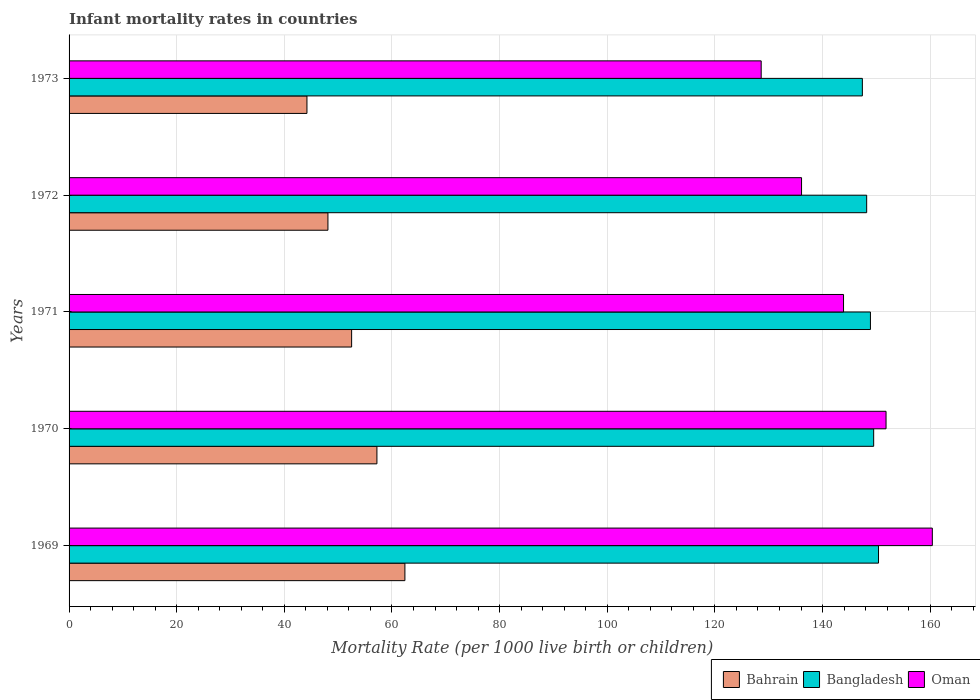How many different coloured bars are there?
Offer a terse response. 3. Are the number of bars per tick equal to the number of legend labels?
Offer a very short reply. Yes. How many bars are there on the 2nd tick from the top?
Ensure brevity in your answer.  3. How many bars are there on the 4th tick from the bottom?
Ensure brevity in your answer.  3. In how many cases, is the number of bars for a given year not equal to the number of legend labels?
Your response must be concise. 0. What is the infant mortality rate in Bahrain in 1970?
Make the answer very short. 57.2. Across all years, what is the maximum infant mortality rate in Oman?
Make the answer very short. 160.4. Across all years, what is the minimum infant mortality rate in Bahrain?
Give a very brief answer. 44.2. In which year was the infant mortality rate in Bahrain maximum?
Your answer should be compact. 1969. In which year was the infant mortality rate in Bahrain minimum?
Your answer should be compact. 1973. What is the total infant mortality rate in Bangladesh in the graph?
Offer a terse response. 744.4. What is the difference between the infant mortality rate in Oman in 1970 and the infant mortality rate in Bahrain in 1971?
Your answer should be very brief. 99.3. What is the average infant mortality rate in Bangladesh per year?
Your answer should be compact. 148.88. In the year 1970, what is the difference between the infant mortality rate in Oman and infant mortality rate in Bangladesh?
Your answer should be very brief. 2.3. In how many years, is the infant mortality rate in Bangladesh greater than 152 ?
Provide a short and direct response. 0. What is the ratio of the infant mortality rate in Bahrain in 1970 to that in 1973?
Offer a very short reply. 1.29. What is the difference between the highest and the second highest infant mortality rate in Bangladesh?
Give a very brief answer. 0.9. In how many years, is the infant mortality rate in Oman greater than the average infant mortality rate in Oman taken over all years?
Provide a short and direct response. 2. What does the 1st bar from the top in 1972 represents?
Your response must be concise. Oman. What does the 2nd bar from the bottom in 1969 represents?
Give a very brief answer. Bangladesh. How many bars are there?
Your answer should be very brief. 15. Does the graph contain any zero values?
Give a very brief answer. No. How many legend labels are there?
Your response must be concise. 3. What is the title of the graph?
Your response must be concise. Infant mortality rates in countries. Does "Antigua and Barbuda" appear as one of the legend labels in the graph?
Your answer should be very brief. No. What is the label or title of the X-axis?
Your answer should be compact. Mortality Rate (per 1000 live birth or children). What is the Mortality Rate (per 1000 live birth or children) of Bahrain in 1969?
Ensure brevity in your answer.  62.4. What is the Mortality Rate (per 1000 live birth or children) of Bangladesh in 1969?
Offer a very short reply. 150.4. What is the Mortality Rate (per 1000 live birth or children) in Oman in 1969?
Provide a short and direct response. 160.4. What is the Mortality Rate (per 1000 live birth or children) of Bahrain in 1970?
Your answer should be very brief. 57.2. What is the Mortality Rate (per 1000 live birth or children) in Bangladesh in 1970?
Ensure brevity in your answer.  149.5. What is the Mortality Rate (per 1000 live birth or children) of Oman in 1970?
Your response must be concise. 151.8. What is the Mortality Rate (per 1000 live birth or children) of Bahrain in 1971?
Your response must be concise. 52.5. What is the Mortality Rate (per 1000 live birth or children) in Bangladesh in 1971?
Provide a succinct answer. 148.9. What is the Mortality Rate (per 1000 live birth or children) of Oman in 1971?
Your response must be concise. 143.9. What is the Mortality Rate (per 1000 live birth or children) of Bahrain in 1972?
Offer a terse response. 48.1. What is the Mortality Rate (per 1000 live birth or children) in Bangladesh in 1972?
Offer a terse response. 148.2. What is the Mortality Rate (per 1000 live birth or children) in Oman in 1972?
Offer a very short reply. 136.1. What is the Mortality Rate (per 1000 live birth or children) of Bahrain in 1973?
Give a very brief answer. 44.2. What is the Mortality Rate (per 1000 live birth or children) of Bangladesh in 1973?
Provide a short and direct response. 147.4. What is the Mortality Rate (per 1000 live birth or children) of Oman in 1973?
Provide a succinct answer. 128.6. Across all years, what is the maximum Mortality Rate (per 1000 live birth or children) of Bahrain?
Make the answer very short. 62.4. Across all years, what is the maximum Mortality Rate (per 1000 live birth or children) in Bangladesh?
Make the answer very short. 150.4. Across all years, what is the maximum Mortality Rate (per 1000 live birth or children) of Oman?
Provide a succinct answer. 160.4. Across all years, what is the minimum Mortality Rate (per 1000 live birth or children) in Bahrain?
Keep it short and to the point. 44.2. Across all years, what is the minimum Mortality Rate (per 1000 live birth or children) in Bangladesh?
Make the answer very short. 147.4. Across all years, what is the minimum Mortality Rate (per 1000 live birth or children) in Oman?
Offer a very short reply. 128.6. What is the total Mortality Rate (per 1000 live birth or children) in Bahrain in the graph?
Give a very brief answer. 264.4. What is the total Mortality Rate (per 1000 live birth or children) of Bangladesh in the graph?
Offer a terse response. 744.4. What is the total Mortality Rate (per 1000 live birth or children) of Oman in the graph?
Ensure brevity in your answer.  720.8. What is the difference between the Mortality Rate (per 1000 live birth or children) in Bahrain in 1969 and that in 1970?
Give a very brief answer. 5.2. What is the difference between the Mortality Rate (per 1000 live birth or children) of Bangladesh in 1969 and that in 1970?
Offer a terse response. 0.9. What is the difference between the Mortality Rate (per 1000 live birth or children) of Oman in 1969 and that in 1970?
Ensure brevity in your answer.  8.6. What is the difference between the Mortality Rate (per 1000 live birth or children) in Bangladesh in 1969 and that in 1971?
Keep it short and to the point. 1.5. What is the difference between the Mortality Rate (per 1000 live birth or children) in Bahrain in 1969 and that in 1972?
Give a very brief answer. 14.3. What is the difference between the Mortality Rate (per 1000 live birth or children) of Bangladesh in 1969 and that in 1972?
Provide a succinct answer. 2.2. What is the difference between the Mortality Rate (per 1000 live birth or children) of Oman in 1969 and that in 1972?
Your answer should be very brief. 24.3. What is the difference between the Mortality Rate (per 1000 live birth or children) of Bahrain in 1969 and that in 1973?
Make the answer very short. 18.2. What is the difference between the Mortality Rate (per 1000 live birth or children) in Bangladesh in 1969 and that in 1973?
Provide a succinct answer. 3. What is the difference between the Mortality Rate (per 1000 live birth or children) of Oman in 1969 and that in 1973?
Your answer should be compact. 31.8. What is the difference between the Mortality Rate (per 1000 live birth or children) in Bahrain in 1970 and that in 1971?
Offer a very short reply. 4.7. What is the difference between the Mortality Rate (per 1000 live birth or children) of Oman in 1970 and that in 1971?
Give a very brief answer. 7.9. What is the difference between the Mortality Rate (per 1000 live birth or children) in Bahrain in 1970 and that in 1972?
Ensure brevity in your answer.  9.1. What is the difference between the Mortality Rate (per 1000 live birth or children) in Bangladesh in 1970 and that in 1972?
Make the answer very short. 1.3. What is the difference between the Mortality Rate (per 1000 live birth or children) of Oman in 1970 and that in 1973?
Keep it short and to the point. 23.2. What is the difference between the Mortality Rate (per 1000 live birth or children) in Bahrain in 1971 and that in 1972?
Make the answer very short. 4.4. What is the difference between the Mortality Rate (per 1000 live birth or children) of Bangladesh in 1971 and that in 1972?
Keep it short and to the point. 0.7. What is the difference between the Mortality Rate (per 1000 live birth or children) in Bangladesh in 1971 and that in 1973?
Your response must be concise. 1.5. What is the difference between the Mortality Rate (per 1000 live birth or children) of Oman in 1971 and that in 1973?
Make the answer very short. 15.3. What is the difference between the Mortality Rate (per 1000 live birth or children) of Bangladesh in 1972 and that in 1973?
Provide a short and direct response. 0.8. What is the difference between the Mortality Rate (per 1000 live birth or children) of Oman in 1972 and that in 1973?
Provide a short and direct response. 7.5. What is the difference between the Mortality Rate (per 1000 live birth or children) of Bahrain in 1969 and the Mortality Rate (per 1000 live birth or children) of Bangladesh in 1970?
Offer a very short reply. -87.1. What is the difference between the Mortality Rate (per 1000 live birth or children) in Bahrain in 1969 and the Mortality Rate (per 1000 live birth or children) in Oman in 1970?
Offer a terse response. -89.4. What is the difference between the Mortality Rate (per 1000 live birth or children) in Bahrain in 1969 and the Mortality Rate (per 1000 live birth or children) in Bangladesh in 1971?
Give a very brief answer. -86.5. What is the difference between the Mortality Rate (per 1000 live birth or children) of Bahrain in 1969 and the Mortality Rate (per 1000 live birth or children) of Oman in 1971?
Provide a succinct answer. -81.5. What is the difference between the Mortality Rate (per 1000 live birth or children) of Bahrain in 1969 and the Mortality Rate (per 1000 live birth or children) of Bangladesh in 1972?
Your answer should be compact. -85.8. What is the difference between the Mortality Rate (per 1000 live birth or children) in Bahrain in 1969 and the Mortality Rate (per 1000 live birth or children) in Oman in 1972?
Your answer should be compact. -73.7. What is the difference between the Mortality Rate (per 1000 live birth or children) in Bahrain in 1969 and the Mortality Rate (per 1000 live birth or children) in Bangladesh in 1973?
Provide a short and direct response. -85. What is the difference between the Mortality Rate (per 1000 live birth or children) of Bahrain in 1969 and the Mortality Rate (per 1000 live birth or children) of Oman in 1973?
Your response must be concise. -66.2. What is the difference between the Mortality Rate (per 1000 live birth or children) of Bangladesh in 1969 and the Mortality Rate (per 1000 live birth or children) of Oman in 1973?
Ensure brevity in your answer.  21.8. What is the difference between the Mortality Rate (per 1000 live birth or children) of Bahrain in 1970 and the Mortality Rate (per 1000 live birth or children) of Bangladesh in 1971?
Offer a terse response. -91.7. What is the difference between the Mortality Rate (per 1000 live birth or children) of Bahrain in 1970 and the Mortality Rate (per 1000 live birth or children) of Oman in 1971?
Keep it short and to the point. -86.7. What is the difference between the Mortality Rate (per 1000 live birth or children) in Bangladesh in 1970 and the Mortality Rate (per 1000 live birth or children) in Oman in 1971?
Provide a short and direct response. 5.6. What is the difference between the Mortality Rate (per 1000 live birth or children) of Bahrain in 1970 and the Mortality Rate (per 1000 live birth or children) of Bangladesh in 1972?
Make the answer very short. -91. What is the difference between the Mortality Rate (per 1000 live birth or children) in Bahrain in 1970 and the Mortality Rate (per 1000 live birth or children) in Oman in 1972?
Your answer should be compact. -78.9. What is the difference between the Mortality Rate (per 1000 live birth or children) in Bangladesh in 1970 and the Mortality Rate (per 1000 live birth or children) in Oman in 1972?
Offer a terse response. 13.4. What is the difference between the Mortality Rate (per 1000 live birth or children) of Bahrain in 1970 and the Mortality Rate (per 1000 live birth or children) of Bangladesh in 1973?
Give a very brief answer. -90.2. What is the difference between the Mortality Rate (per 1000 live birth or children) of Bahrain in 1970 and the Mortality Rate (per 1000 live birth or children) of Oman in 1973?
Your response must be concise. -71.4. What is the difference between the Mortality Rate (per 1000 live birth or children) in Bangladesh in 1970 and the Mortality Rate (per 1000 live birth or children) in Oman in 1973?
Provide a succinct answer. 20.9. What is the difference between the Mortality Rate (per 1000 live birth or children) in Bahrain in 1971 and the Mortality Rate (per 1000 live birth or children) in Bangladesh in 1972?
Ensure brevity in your answer.  -95.7. What is the difference between the Mortality Rate (per 1000 live birth or children) of Bahrain in 1971 and the Mortality Rate (per 1000 live birth or children) of Oman in 1972?
Ensure brevity in your answer.  -83.6. What is the difference between the Mortality Rate (per 1000 live birth or children) in Bangladesh in 1971 and the Mortality Rate (per 1000 live birth or children) in Oman in 1972?
Your answer should be very brief. 12.8. What is the difference between the Mortality Rate (per 1000 live birth or children) of Bahrain in 1971 and the Mortality Rate (per 1000 live birth or children) of Bangladesh in 1973?
Provide a short and direct response. -94.9. What is the difference between the Mortality Rate (per 1000 live birth or children) in Bahrain in 1971 and the Mortality Rate (per 1000 live birth or children) in Oman in 1973?
Your answer should be compact. -76.1. What is the difference between the Mortality Rate (per 1000 live birth or children) of Bangladesh in 1971 and the Mortality Rate (per 1000 live birth or children) of Oman in 1973?
Your answer should be compact. 20.3. What is the difference between the Mortality Rate (per 1000 live birth or children) in Bahrain in 1972 and the Mortality Rate (per 1000 live birth or children) in Bangladesh in 1973?
Offer a very short reply. -99.3. What is the difference between the Mortality Rate (per 1000 live birth or children) in Bahrain in 1972 and the Mortality Rate (per 1000 live birth or children) in Oman in 1973?
Give a very brief answer. -80.5. What is the difference between the Mortality Rate (per 1000 live birth or children) of Bangladesh in 1972 and the Mortality Rate (per 1000 live birth or children) of Oman in 1973?
Your answer should be very brief. 19.6. What is the average Mortality Rate (per 1000 live birth or children) of Bahrain per year?
Provide a short and direct response. 52.88. What is the average Mortality Rate (per 1000 live birth or children) in Bangladesh per year?
Keep it short and to the point. 148.88. What is the average Mortality Rate (per 1000 live birth or children) in Oman per year?
Your answer should be very brief. 144.16. In the year 1969, what is the difference between the Mortality Rate (per 1000 live birth or children) in Bahrain and Mortality Rate (per 1000 live birth or children) in Bangladesh?
Ensure brevity in your answer.  -88. In the year 1969, what is the difference between the Mortality Rate (per 1000 live birth or children) in Bahrain and Mortality Rate (per 1000 live birth or children) in Oman?
Provide a short and direct response. -98. In the year 1970, what is the difference between the Mortality Rate (per 1000 live birth or children) of Bahrain and Mortality Rate (per 1000 live birth or children) of Bangladesh?
Your answer should be compact. -92.3. In the year 1970, what is the difference between the Mortality Rate (per 1000 live birth or children) in Bahrain and Mortality Rate (per 1000 live birth or children) in Oman?
Ensure brevity in your answer.  -94.6. In the year 1970, what is the difference between the Mortality Rate (per 1000 live birth or children) in Bangladesh and Mortality Rate (per 1000 live birth or children) in Oman?
Offer a terse response. -2.3. In the year 1971, what is the difference between the Mortality Rate (per 1000 live birth or children) of Bahrain and Mortality Rate (per 1000 live birth or children) of Bangladesh?
Ensure brevity in your answer.  -96.4. In the year 1971, what is the difference between the Mortality Rate (per 1000 live birth or children) of Bahrain and Mortality Rate (per 1000 live birth or children) of Oman?
Offer a very short reply. -91.4. In the year 1972, what is the difference between the Mortality Rate (per 1000 live birth or children) of Bahrain and Mortality Rate (per 1000 live birth or children) of Bangladesh?
Ensure brevity in your answer.  -100.1. In the year 1972, what is the difference between the Mortality Rate (per 1000 live birth or children) of Bahrain and Mortality Rate (per 1000 live birth or children) of Oman?
Provide a short and direct response. -88. In the year 1973, what is the difference between the Mortality Rate (per 1000 live birth or children) in Bahrain and Mortality Rate (per 1000 live birth or children) in Bangladesh?
Keep it short and to the point. -103.2. In the year 1973, what is the difference between the Mortality Rate (per 1000 live birth or children) in Bahrain and Mortality Rate (per 1000 live birth or children) in Oman?
Provide a succinct answer. -84.4. In the year 1973, what is the difference between the Mortality Rate (per 1000 live birth or children) of Bangladesh and Mortality Rate (per 1000 live birth or children) of Oman?
Your answer should be compact. 18.8. What is the ratio of the Mortality Rate (per 1000 live birth or children) in Bahrain in 1969 to that in 1970?
Offer a terse response. 1.09. What is the ratio of the Mortality Rate (per 1000 live birth or children) in Bangladesh in 1969 to that in 1970?
Ensure brevity in your answer.  1.01. What is the ratio of the Mortality Rate (per 1000 live birth or children) of Oman in 1969 to that in 1970?
Keep it short and to the point. 1.06. What is the ratio of the Mortality Rate (per 1000 live birth or children) of Bahrain in 1969 to that in 1971?
Offer a terse response. 1.19. What is the ratio of the Mortality Rate (per 1000 live birth or children) of Bangladesh in 1969 to that in 1971?
Your response must be concise. 1.01. What is the ratio of the Mortality Rate (per 1000 live birth or children) in Oman in 1969 to that in 1971?
Your response must be concise. 1.11. What is the ratio of the Mortality Rate (per 1000 live birth or children) in Bahrain in 1969 to that in 1972?
Make the answer very short. 1.3. What is the ratio of the Mortality Rate (per 1000 live birth or children) in Bangladesh in 1969 to that in 1972?
Ensure brevity in your answer.  1.01. What is the ratio of the Mortality Rate (per 1000 live birth or children) in Oman in 1969 to that in 1972?
Your response must be concise. 1.18. What is the ratio of the Mortality Rate (per 1000 live birth or children) of Bahrain in 1969 to that in 1973?
Give a very brief answer. 1.41. What is the ratio of the Mortality Rate (per 1000 live birth or children) of Bangladesh in 1969 to that in 1973?
Your answer should be very brief. 1.02. What is the ratio of the Mortality Rate (per 1000 live birth or children) of Oman in 1969 to that in 1973?
Your answer should be compact. 1.25. What is the ratio of the Mortality Rate (per 1000 live birth or children) of Bahrain in 1970 to that in 1971?
Your answer should be compact. 1.09. What is the ratio of the Mortality Rate (per 1000 live birth or children) in Oman in 1970 to that in 1971?
Your response must be concise. 1.05. What is the ratio of the Mortality Rate (per 1000 live birth or children) in Bahrain in 1970 to that in 1972?
Offer a terse response. 1.19. What is the ratio of the Mortality Rate (per 1000 live birth or children) in Bangladesh in 1970 to that in 1972?
Offer a very short reply. 1.01. What is the ratio of the Mortality Rate (per 1000 live birth or children) in Oman in 1970 to that in 1972?
Your answer should be compact. 1.12. What is the ratio of the Mortality Rate (per 1000 live birth or children) of Bahrain in 1970 to that in 1973?
Your response must be concise. 1.29. What is the ratio of the Mortality Rate (per 1000 live birth or children) in Bangladesh in 1970 to that in 1973?
Your response must be concise. 1.01. What is the ratio of the Mortality Rate (per 1000 live birth or children) of Oman in 1970 to that in 1973?
Offer a terse response. 1.18. What is the ratio of the Mortality Rate (per 1000 live birth or children) of Bahrain in 1971 to that in 1972?
Your response must be concise. 1.09. What is the ratio of the Mortality Rate (per 1000 live birth or children) of Bangladesh in 1971 to that in 1972?
Provide a succinct answer. 1. What is the ratio of the Mortality Rate (per 1000 live birth or children) in Oman in 1971 to that in 1972?
Offer a terse response. 1.06. What is the ratio of the Mortality Rate (per 1000 live birth or children) of Bahrain in 1971 to that in 1973?
Your answer should be very brief. 1.19. What is the ratio of the Mortality Rate (per 1000 live birth or children) of Bangladesh in 1971 to that in 1973?
Provide a succinct answer. 1.01. What is the ratio of the Mortality Rate (per 1000 live birth or children) of Oman in 1971 to that in 1973?
Give a very brief answer. 1.12. What is the ratio of the Mortality Rate (per 1000 live birth or children) of Bahrain in 1972 to that in 1973?
Your answer should be very brief. 1.09. What is the ratio of the Mortality Rate (per 1000 live birth or children) in Bangladesh in 1972 to that in 1973?
Make the answer very short. 1.01. What is the ratio of the Mortality Rate (per 1000 live birth or children) of Oman in 1972 to that in 1973?
Your response must be concise. 1.06. What is the difference between the highest and the second highest Mortality Rate (per 1000 live birth or children) in Bahrain?
Your answer should be very brief. 5.2. What is the difference between the highest and the second highest Mortality Rate (per 1000 live birth or children) of Oman?
Provide a short and direct response. 8.6. What is the difference between the highest and the lowest Mortality Rate (per 1000 live birth or children) of Bahrain?
Offer a very short reply. 18.2. What is the difference between the highest and the lowest Mortality Rate (per 1000 live birth or children) of Bangladesh?
Your response must be concise. 3. What is the difference between the highest and the lowest Mortality Rate (per 1000 live birth or children) of Oman?
Provide a short and direct response. 31.8. 